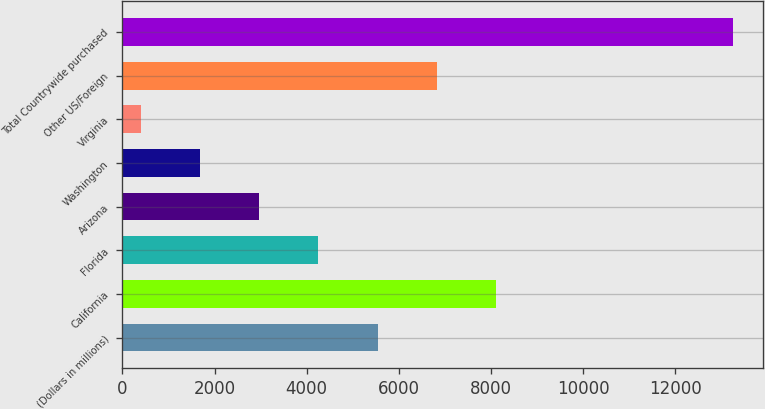Convert chart to OTSL. <chart><loc_0><loc_0><loc_500><loc_500><bar_chart><fcel>(Dollars in millions)<fcel>California<fcel>Florida<fcel>Arizona<fcel>Washington<fcel>Virginia<fcel>Other US/Foreign<fcel>Total Countrywide purchased<nl><fcel>5539.4<fcel>8109.6<fcel>4254.3<fcel>2969.2<fcel>1684.1<fcel>399<fcel>6824.5<fcel>13250<nl></chart> 